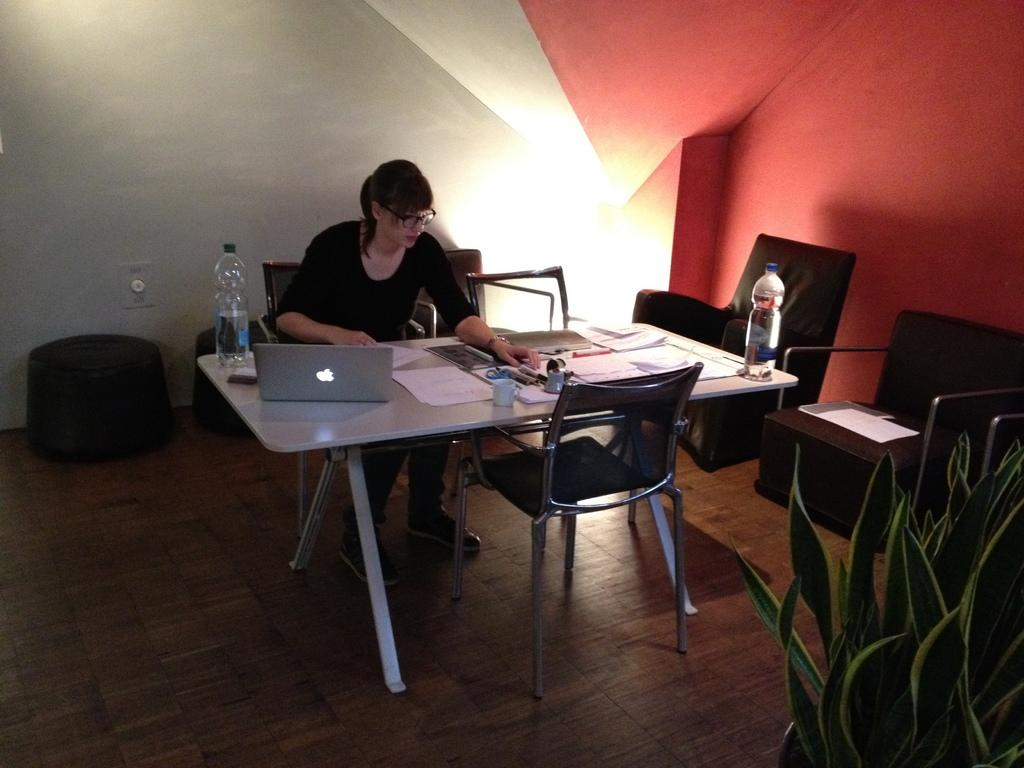Who is the main subject in the picture? There is a woman in the picture. What is the woman doing in the image? The woman is sitting in front of a table and working on a laptop. What can be seen on the table in the image? There are many items on the table. What type of word is being exchanged between the woman and the potato in the image? There is no potato present in the image, and therefore no such exchange can be observed. 